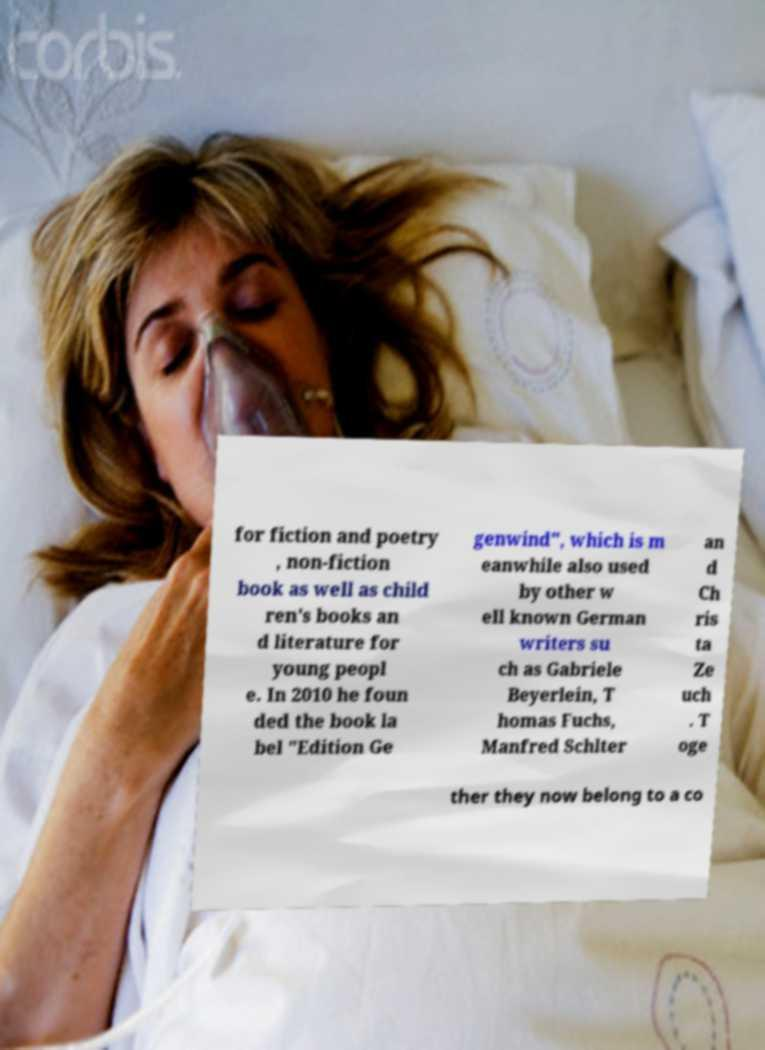Please identify and transcribe the text found in this image. for fiction and poetry , non-fiction book as well as child ren's books an d literature for young peopl e. In 2010 he foun ded the book la bel "Edition Ge genwind", which is m eanwhile also used by other w ell known German writers su ch as Gabriele Beyerlein, T homas Fuchs, Manfred Schlter an d Ch ris ta Ze uch . T oge ther they now belong to a co 